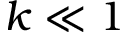Convert formula to latex. <formula><loc_0><loc_0><loc_500><loc_500>k \ll 1</formula> 